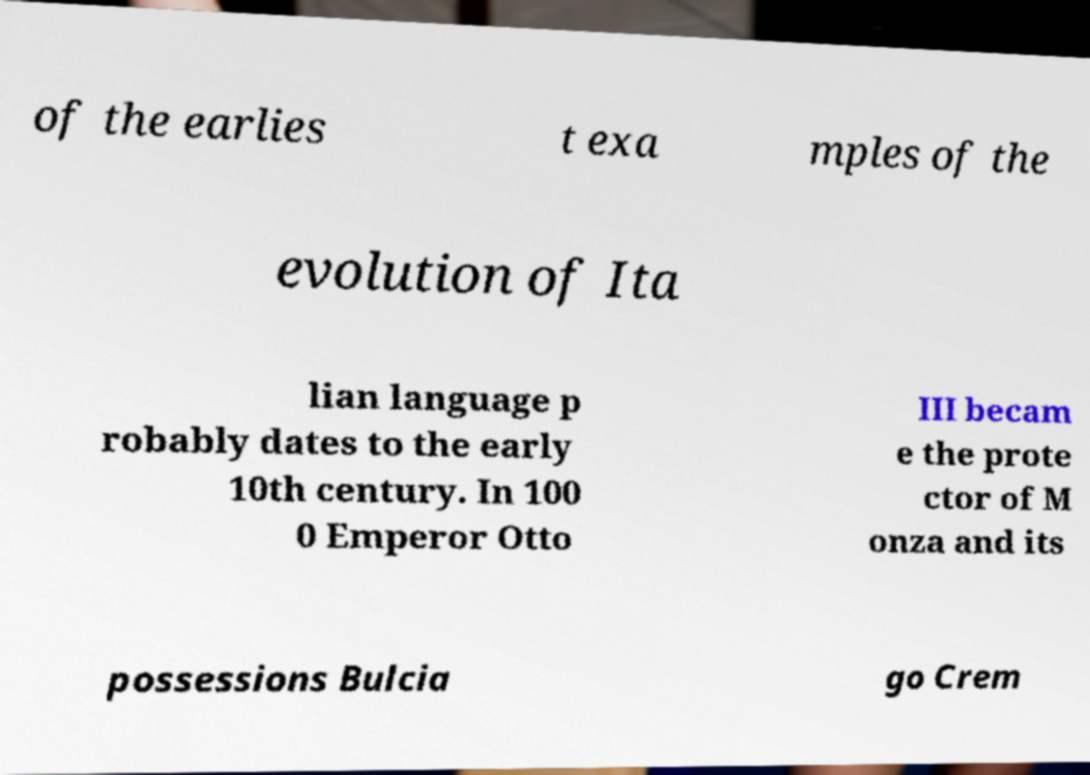Can you accurately transcribe the text from the provided image for me? of the earlies t exa mples of the evolution of Ita lian language p robably dates to the early 10th century. In 100 0 Emperor Otto III becam e the prote ctor of M onza and its possessions Bulcia go Crem 